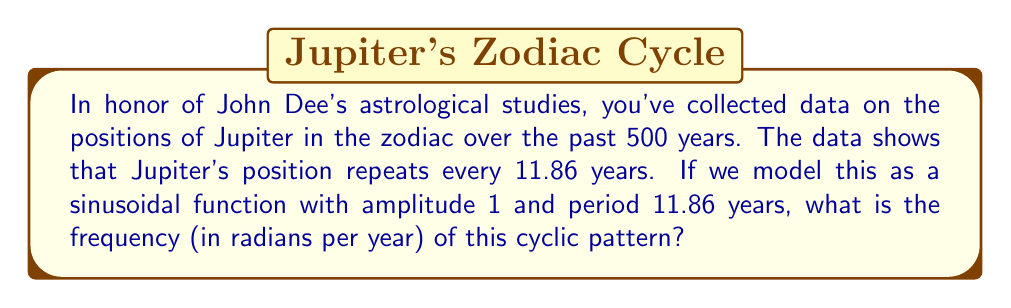Can you solve this math problem? To solve this problem, we need to understand the relationship between period and frequency in cyclic patterns. In time series analysis, particularly when dealing with astronomical data, this relationship is crucial.

1) The general form of a sinusoidal function is:

   $$f(t) = A \sin(\omega t + \phi)$$

   Where:
   - $A$ is the amplitude (given as 1 in this case)
   - $\omega$ is the angular frequency (in radians per unit time)
   - $t$ is time
   - $\phi$ is the phase shift

2) We're given the period $T = 11.86$ years. The relationship between period and angular frequency is:

   $$\omega = \frac{2\pi}{T}$$

3) Substituting our known value:

   $$\omega = \frac{2\pi}{11.86}$$

4) Simplifying:

   $$\omega \approx 0.5298 \text{ radians per year}$$

This frequency represents how quickly Jupiter moves through its cycle in the zodiac, which would have been of great interest to John Dee in his astrological studies.
Answer: $\omega \approx 0.5298 \text{ radians per year}$ 